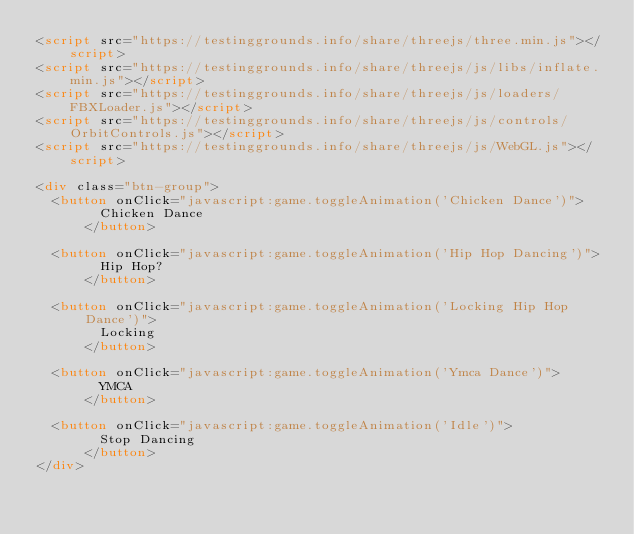Convert code to text. <code><loc_0><loc_0><loc_500><loc_500><_HTML_><script src="https://testinggrounds.info/share/threejs/three.min.js"></script>
<script src="https://testinggrounds.info/share/threejs/js/libs/inflate.min.js"></script>
<script src="https://testinggrounds.info/share/threejs/js/loaders/FBXLoader.js"></script>
<script src="https://testinggrounds.info/share/threejs/js/controls/OrbitControls.js"></script>
<script src="https://testinggrounds.info/share/threejs/js/WebGL.js"></script>

<div class="btn-group">
  <button onClick="javascript:game.toggleAnimation('Chicken Dance')">
        Chicken Dance
      </button>

  <button onClick="javascript:game.toggleAnimation('Hip Hop Dancing')">
        Hip Hop?
      </button>

  <button onClick="javascript:game.toggleAnimation('Locking Hip Hop Dance')">
        Locking
      </button>

  <button onClick="javascript:game.toggleAnimation('Ymca Dance')">
        YMCA
      </button>

  <button onClick="javascript:game.toggleAnimation('Idle')">
        Stop Dancing
      </button>
</div></code> 